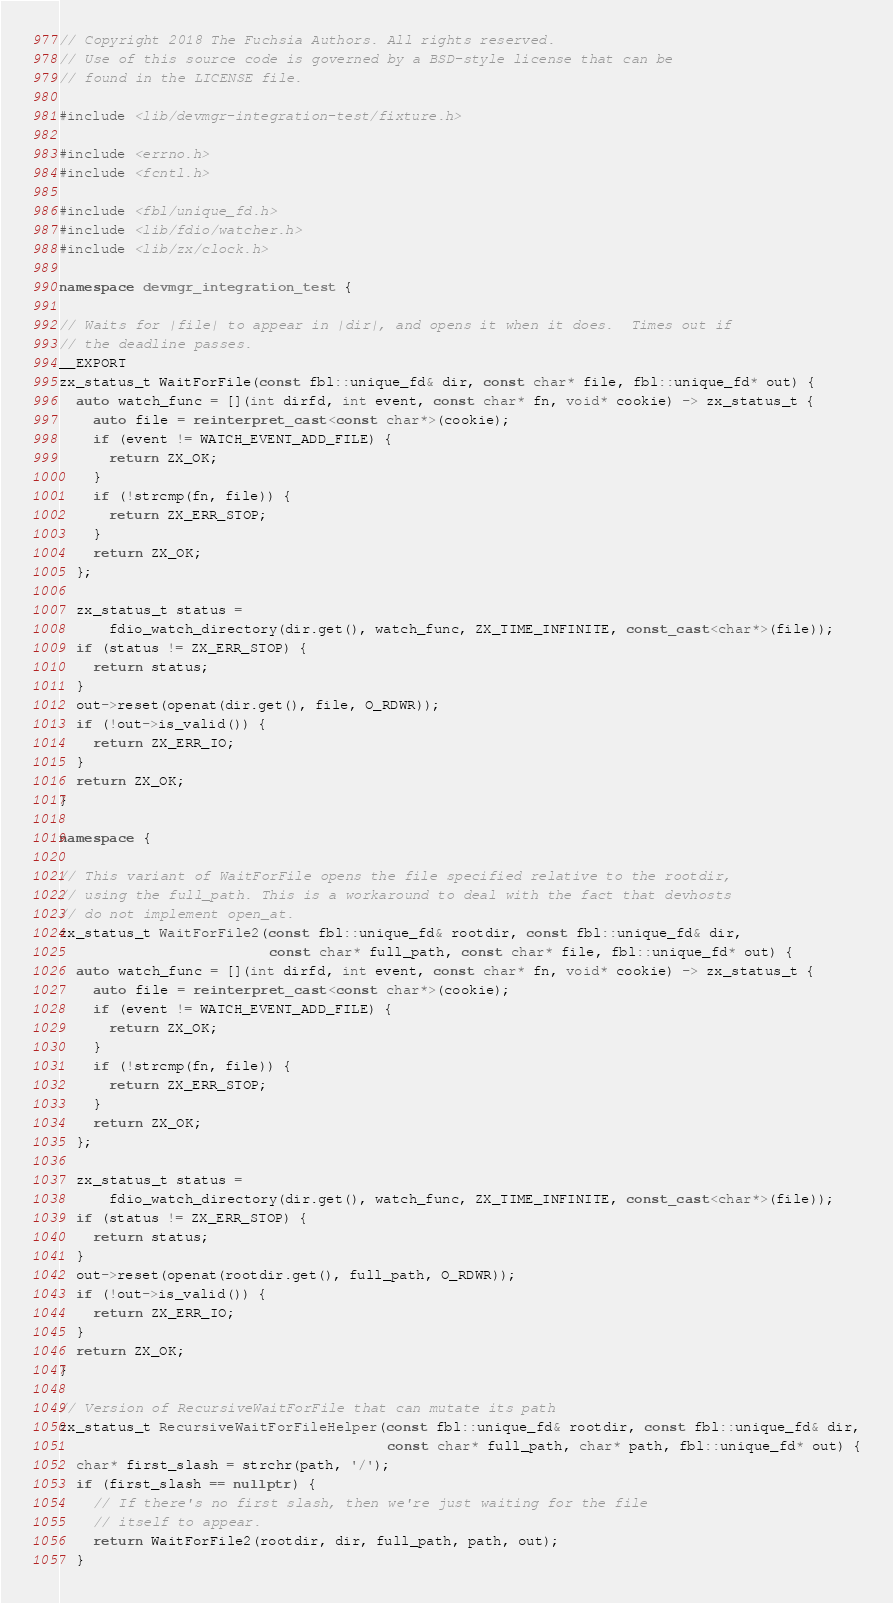<code> <loc_0><loc_0><loc_500><loc_500><_C++_>// Copyright 2018 The Fuchsia Authors. All rights reserved.
// Use of this source code is governed by a BSD-style license that can be
// found in the LICENSE file.

#include <lib/devmgr-integration-test/fixture.h>

#include <errno.h>
#include <fcntl.h>

#include <fbl/unique_fd.h>
#include <lib/fdio/watcher.h>
#include <lib/zx/clock.h>

namespace devmgr_integration_test {

// Waits for |file| to appear in |dir|, and opens it when it does.  Times out if
// the deadline passes.
__EXPORT
zx_status_t WaitForFile(const fbl::unique_fd& dir, const char* file, fbl::unique_fd* out) {
  auto watch_func = [](int dirfd, int event, const char* fn, void* cookie) -> zx_status_t {
    auto file = reinterpret_cast<const char*>(cookie);
    if (event != WATCH_EVENT_ADD_FILE) {
      return ZX_OK;
    }
    if (!strcmp(fn, file)) {
      return ZX_ERR_STOP;
    }
    return ZX_OK;
  };

  zx_status_t status =
      fdio_watch_directory(dir.get(), watch_func, ZX_TIME_INFINITE, const_cast<char*>(file));
  if (status != ZX_ERR_STOP) {
    return status;
  }
  out->reset(openat(dir.get(), file, O_RDWR));
  if (!out->is_valid()) {
    return ZX_ERR_IO;
  }
  return ZX_OK;
}

namespace {

// This variant of WaitForFile opens the file specified relative to the rootdir,
// using the full_path. This is a workaround to deal with the fact that devhosts
// do not implement open_at.
zx_status_t WaitForFile2(const fbl::unique_fd& rootdir, const fbl::unique_fd& dir,
                         const char* full_path, const char* file, fbl::unique_fd* out) {
  auto watch_func = [](int dirfd, int event, const char* fn, void* cookie) -> zx_status_t {
    auto file = reinterpret_cast<const char*>(cookie);
    if (event != WATCH_EVENT_ADD_FILE) {
      return ZX_OK;
    }
    if (!strcmp(fn, file)) {
      return ZX_ERR_STOP;
    }
    return ZX_OK;
  };

  zx_status_t status =
      fdio_watch_directory(dir.get(), watch_func, ZX_TIME_INFINITE, const_cast<char*>(file));
  if (status != ZX_ERR_STOP) {
    return status;
  }
  out->reset(openat(rootdir.get(), full_path, O_RDWR));
  if (!out->is_valid()) {
    return ZX_ERR_IO;
  }
  return ZX_OK;
}

// Version of RecursiveWaitForFile that can mutate its path
zx_status_t RecursiveWaitForFileHelper(const fbl::unique_fd& rootdir, const fbl::unique_fd& dir,
                                       const char* full_path, char* path, fbl::unique_fd* out) {
  char* first_slash = strchr(path, '/');
  if (first_slash == nullptr) {
    // If there's no first slash, then we're just waiting for the file
    // itself to appear.
    return WaitForFile2(rootdir, dir, full_path, path, out);
  }</code> 